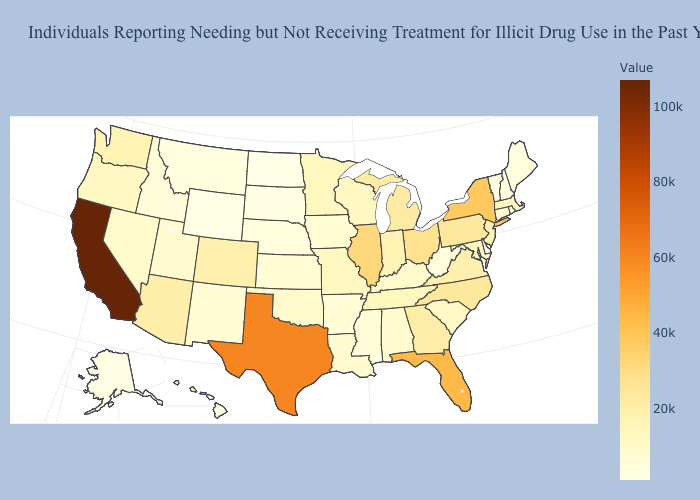Among the states that border Oregon , does Idaho have the lowest value?
Concise answer only. Yes. Does the map have missing data?
Be succinct. No. Among the states that border Kentucky , which have the highest value?
Write a very short answer. Illinois. 